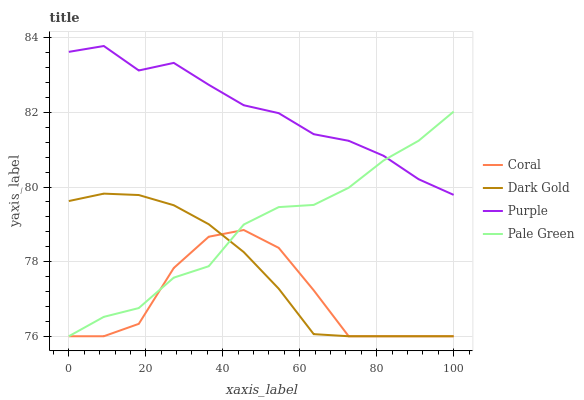Does Coral have the minimum area under the curve?
Answer yes or no. Yes. Does Purple have the maximum area under the curve?
Answer yes or no. Yes. Does Pale Green have the minimum area under the curve?
Answer yes or no. No. Does Pale Green have the maximum area under the curve?
Answer yes or no. No. Is Dark Gold the smoothest?
Answer yes or no. Yes. Is Coral the roughest?
Answer yes or no. Yes. Is Pale Green the smoothest?
Answer yes or no. No. Is Pale Green the roughest?
Answer yes or no. No. Does Coral have the lowest value?
Answer yes or no. Yes. Does Purple have the highest value?
Answer yes or no. Yes. Does Pale Green have the highest value?
Answer yes or no. No. Is Coral less than Purple?
Answer yes or no. Yes. Is Purple greater than Coral?
Answer yes or no. Yes. Does Coral intersect Pale Green?
Answer yes or no. Yes. Is Coral less than Pale Green?
Answer yes or no. No. Is Coral greater than Pale Green?
Answer yes or no. No. Does Coral intersect Purple?
Answer yes or no. No. 